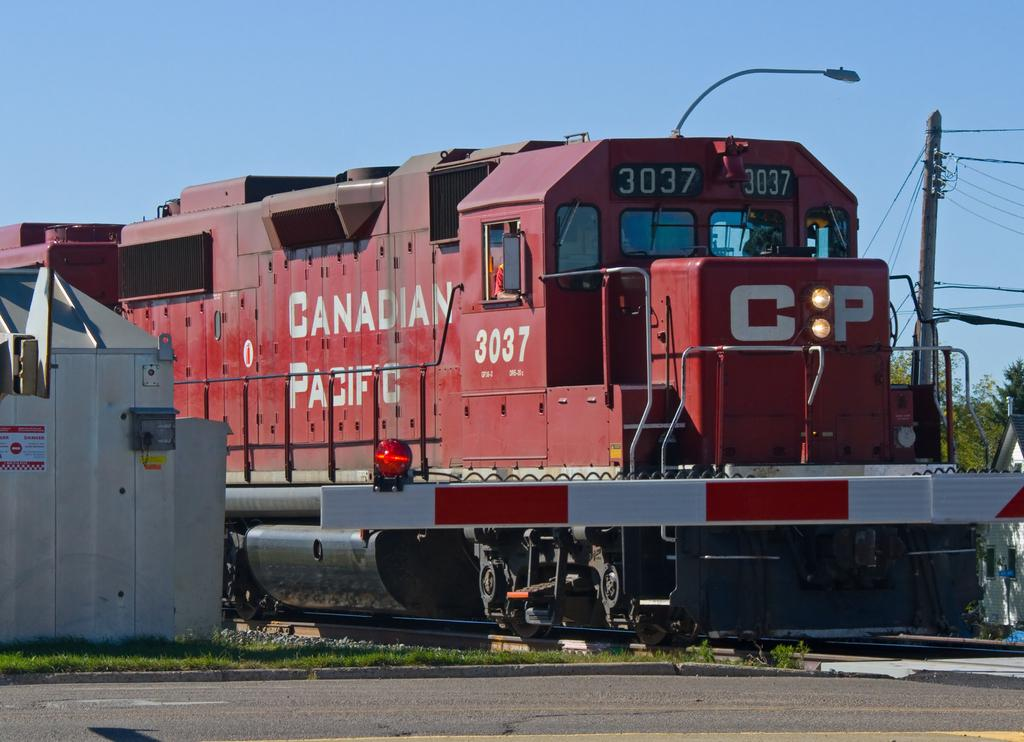What is the main subject of the image? The main subject of the image is a train. Where is the train located? The train is on a railway track. What can be seen in the background of the image? In the background of the image, there is sky, a street light, a pole, electric cables, trees, grass, and a road. What type of acoustics can be heard coming from the window in the image? There is no window present in the image, so it is not possible to determine the acoustics. 